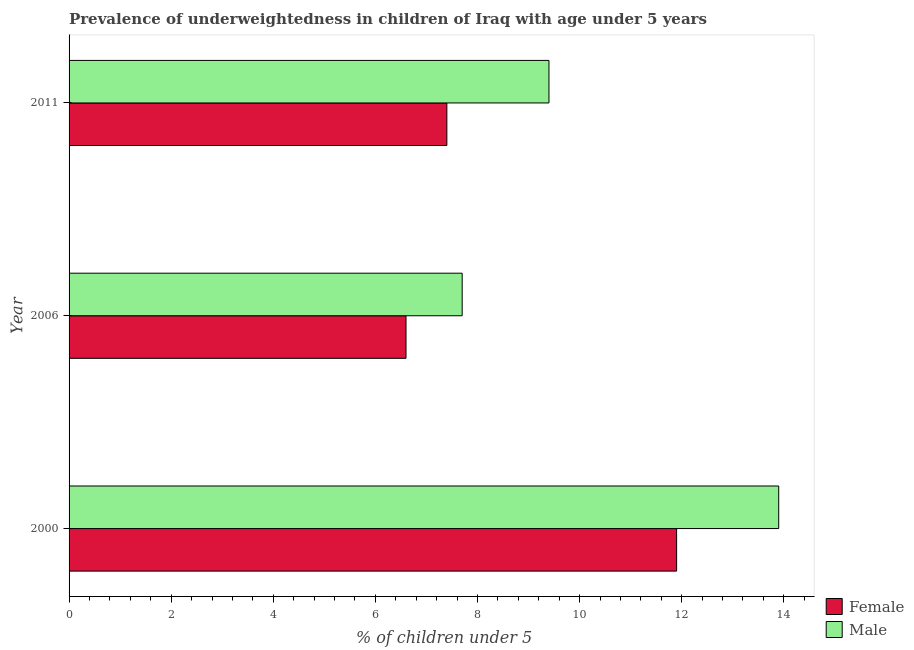How many bars are there on the 3rd tick from the top?
Ensure brevity in your answer.  2. How many bars are there on the 3rd tick from the bottom?
Provide a short and direct response. 2. What is the percentage of underweighted female children in 2011?
Provide a short and direct response. 7.4. Across all years, what is the maximum percentage of underweighted male children?
Your answer should be very brief. 13.9. Across all years, what is the minimum percentage of underweighted female children?
Offer a very short reply. 6.6. What is the total percentage of underweighted female children in the graph?
Give a very brief answer. 25.9. What is the difference between the percentage of underweighted female children in 2006 and that in 2011?
Your response must be concise. -0.8. What is the difference between the percentage of underweighted female children in 2006 and the percentage of underweighted male children in 2011?
Ensure brevity in your answer.  -2.8. What is the average percentage of underweighted female children per year?
Your answer should be compact. 8.63. In the year 2006, what is the difference between the percentage of underweighted female children and percentage of underweighted male children?
Your answer should be compact. -1.1. What is the ratio of the percentage of underweighted male children in 2006 to that in 2011?
Provide a succinct answer. 0.82. What is the difference between the highest and the second highest percentage of underweighted male children?
Offer a very short reply. 4.5. In how many years, is the percentage of underweighted female children greater than the average percentage of underweighted female children taken over all years?
Offer a very short reply. 1. Is the sum of the percentage of underweighted male children in 2000 and 2011 greater than the maximum percentage of underweighted female children across all years?
Offer a very short reply. Yes. How many bars are there?
Ensure brevity in your answer.  6. Does the graph contain grids?
Your answer should be compact. No. Where does the legend appear in the graph?
Your answer should be compact. Bottom right. What is the title of the graph?
Offer a terse response. Prevalence of underweightedness in children of Iraq with age under 5 years. Does "Rural Population" appear as one of the legend labels in the graph?
Give a very brief answer. No. What is the label or title of the X-axis?
Your answer should be very brief.  % of children under 5. What is the  % of children under 5 in Female in 2000?
Offer a terse response. 11.9. What is the  % of children under 5 in Male in 2000?
Ensure brevity in your answer.  13.9. What is the  % of children under 5 of Female in 2006?
Your response must be concise. 6.6. What is the  % of children under 5 of Male in 2006?
Make the answer very short. 7.7. What is the  % of children under 5 of Female in 2011?
Your answer should be very brief. 7.4. What is the  % of children under 5 in Male in 2011?
Offer a very short reply. 9.4. Across all years, what is the maximum  % of children under 5 in Female?
Your answer should be compact. 11.9. Across all years, what is the maximum  % of children under 5 in Male?
Provide a short and direct response. 13.9. Across all years, what is the minimum  % of children under 5 in Female?
Your answer should be compact. 6.6. Across all years, what is the minimum  % of children under 5 of Male?
Your answer should be compact. 7.7. What is the total  % of children under 5 of Female in the graph?
Provide a short and direct response. 25.9. What is the total  % of children under 5 in Male in the graph?
Offer a very short reply. 31. What is the difference between the  % of children under 5 of Female in 2000 and that in 2006?
Give a very brief answer. 5.3. What is the difference between the  % of children under 5 in Male in 2000 and that in 2006?
Provide a succinct answer. 6.2. What is the difference between the  % of children under 5 of Male in 2000 and that in 2011?
Your response must be concise. 4.5. What is the difference between the  % of children under 5 of Female in 2006 and that in 2011?
Offer a terse response. -0.8. What is the difference between the  % of children under 5 in Male in 2006 and that in 2011?
Provide a succinct answer. -1.7. What is the difference between the  % of children under 5 in Female in 2000 and the  % of children under 5 in Male in 2011?
Your answer should be compact. 2.5. What is the difference between the  % of children under 5 of Female in 2006 and the  % of children under 5 of Male in 2011?
Your response must be concise. -2.8. What is the average  % of children under 5 of Female per year?
Your answer should be compact. 8.63. What is the average  % of children under 5 of Male per year?
Offer a very short reply. 10.33. What is the ratio of the  % of children under 5 of Female in 2000 to that in 2006?
Give a very brief answer. 1.8. What is the ratio of the  % of children under 5 in Male in 2000 to that in 2006?
Your response must be concise. 1.81. What is the ratio of the  % of children under 5 of Female in 2000 to that in 2011?
Provide a succinct answer. 1.61. What is the ratio of the  % of children under 5 of Male in 2000 to that in 2011?
Keep it short and to the point. 1.48. What is the ratio of the  % of children under 5 in Female in 2006 to that in 2011?
Give a very brief answer. 0.89. What is the ratio of the  % of children under 5 in Male in 2006 to that in 2011?
Provide a short and direct response. 0.82. What is the difference between the highest and the second highest  % of children under 5 in Male?
Your response must be concise. 4.5. 